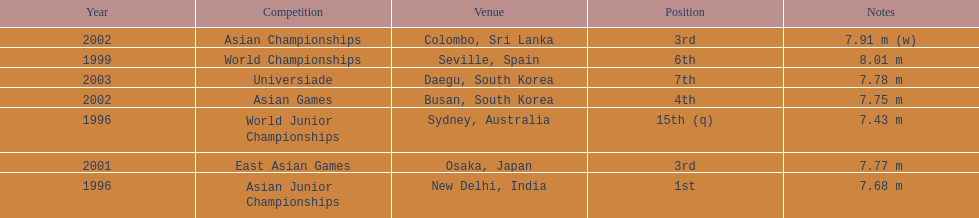In how many contests did he achieve a top-three position? 3. 